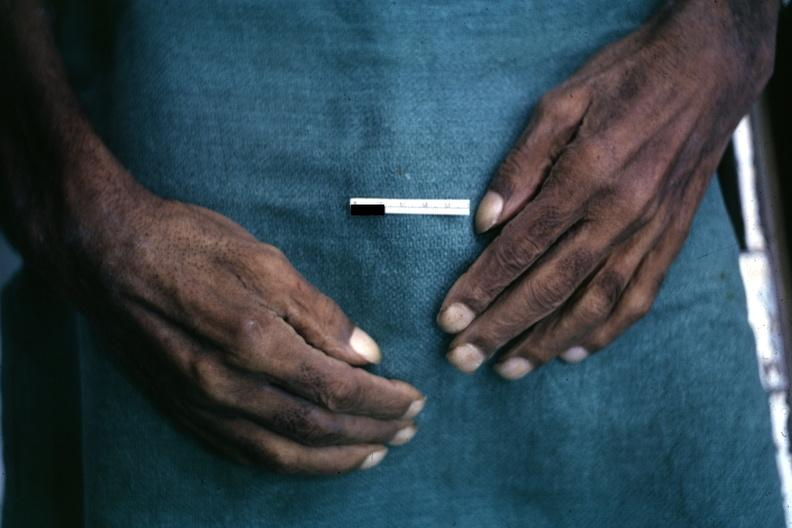s cachexia present?
Answer the question using a single word or phrase. No 